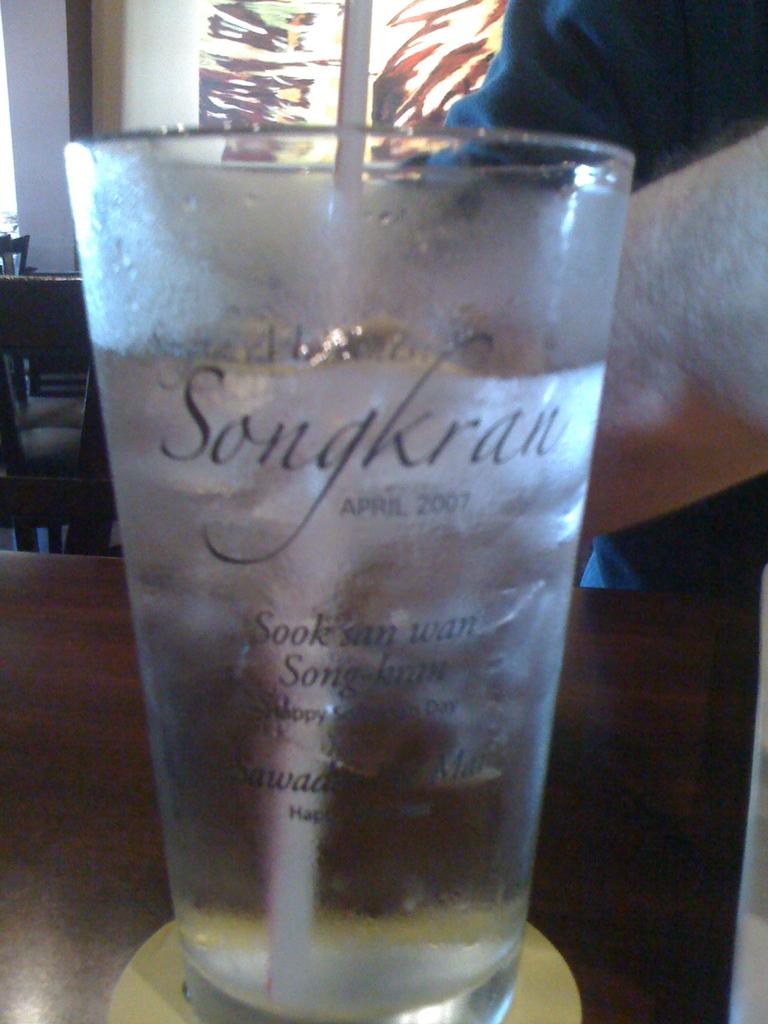What is the drink in the cup?
Keep it short and to the point. Songkran. What is the name on the cup?
Provide a succinct answer. Songkran. 